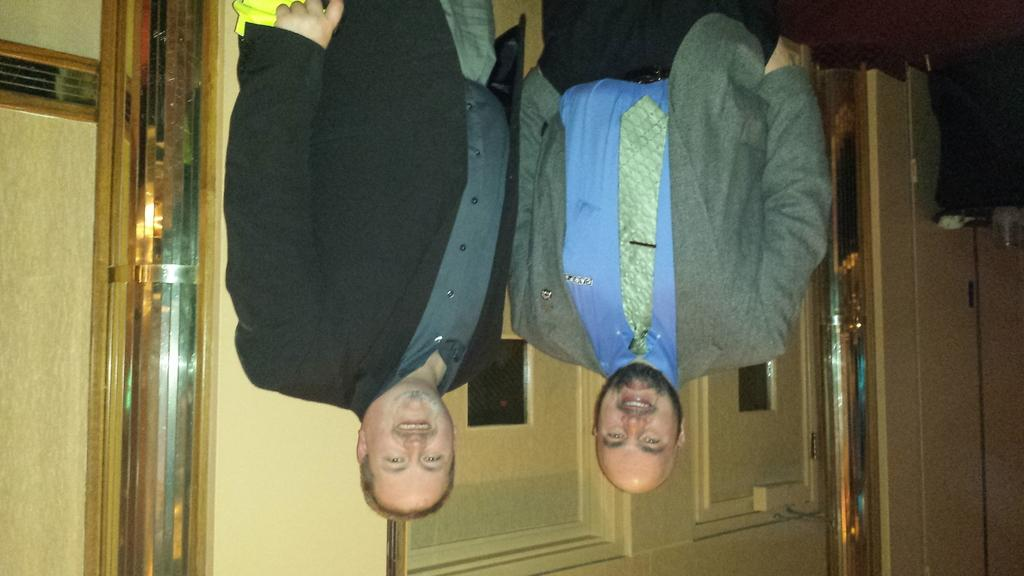How many people are in the image? There are two persons in the image. Where are the persons located in the image? The persons are standing in the middle of the image. What is at the bottom of the image? There is a wall at the bottom of the image. What is the topic of the discussion between the man and his elbow in the image? There is no man or discussion present in the image; it features two persons standing in the middle. 